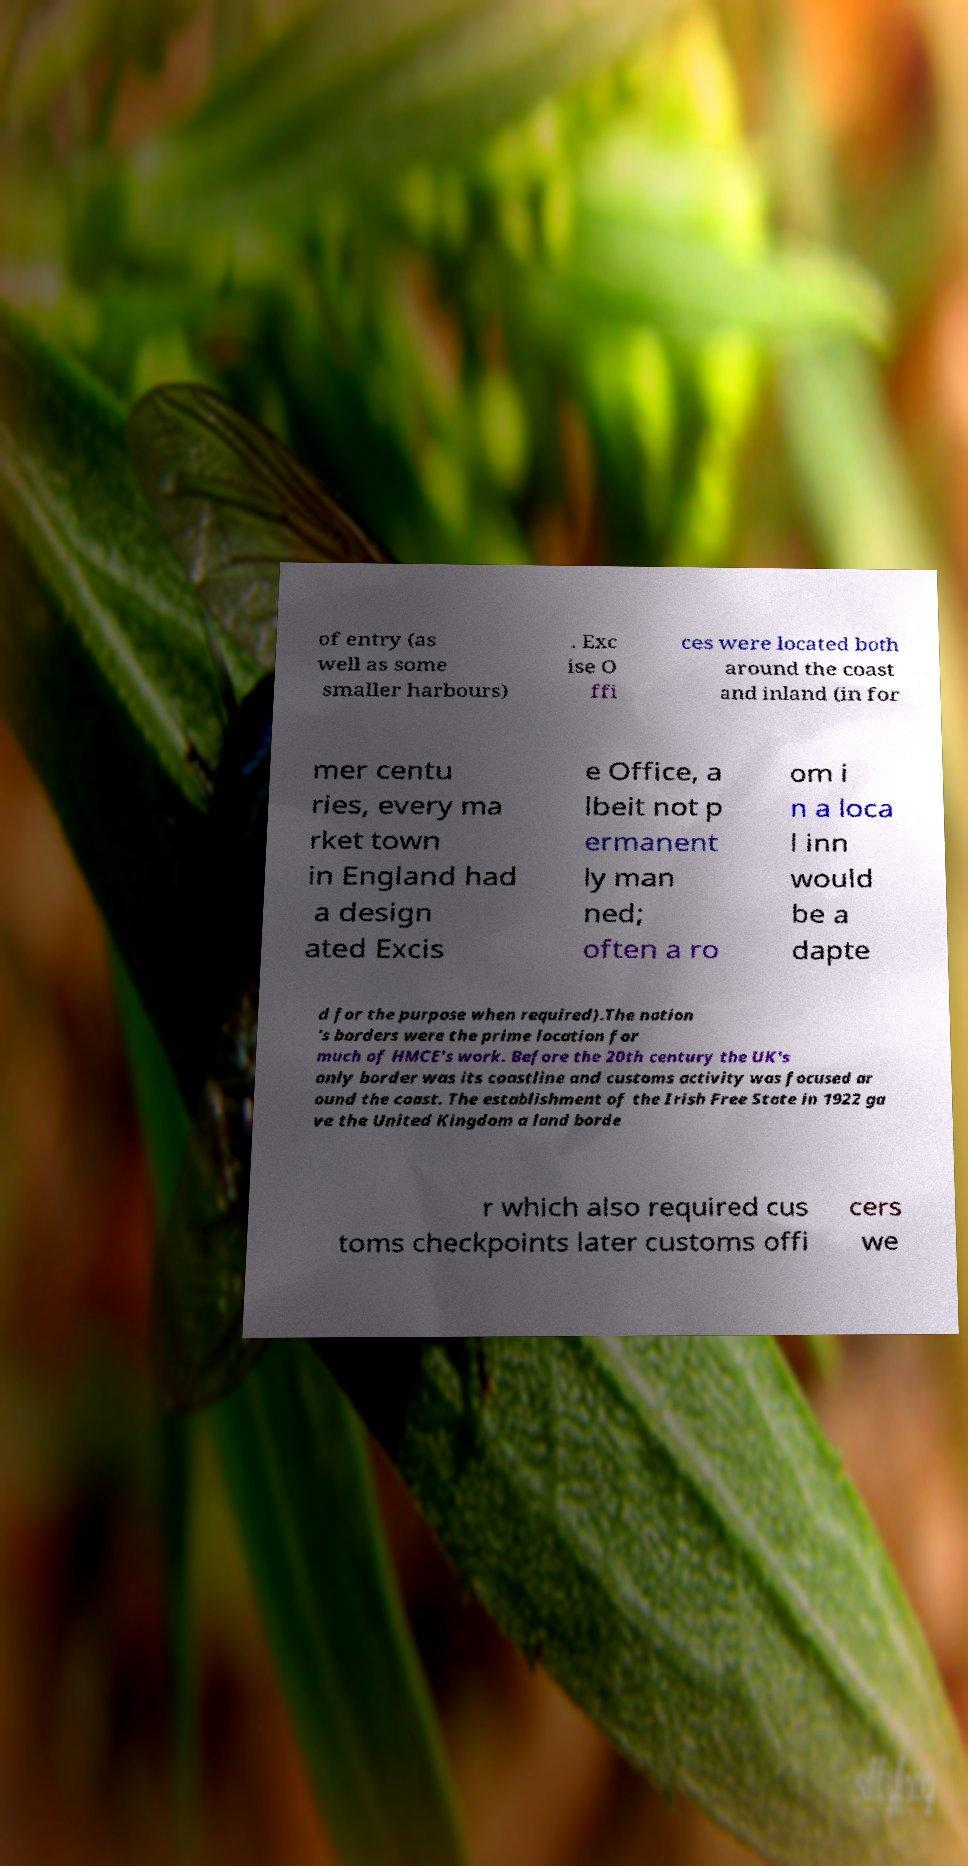There's text embedded in this image that I need extracted. Can you transcribe it verbatim? of entry (as well as some smaller harbours) . Exc ise O ffi ces were located both around the coast and inland (in for mer centu ries, every ma rket town in England had a design ated Excis e Office, a lbeit not p ermanent ly man ned; often a ro om i n a loca l inn would be a dapte d for the purpose when required).The nation 's borders were the prime location for much of HMCE's work. Before the 20th century the UK's only border was its coastline and customs activity was focused ar ound the coast. The establishment of the Irish Free State in 1922 ga ve the United Kingdom a land borde r which also required cus toms checkpoints later customs offi cers we 